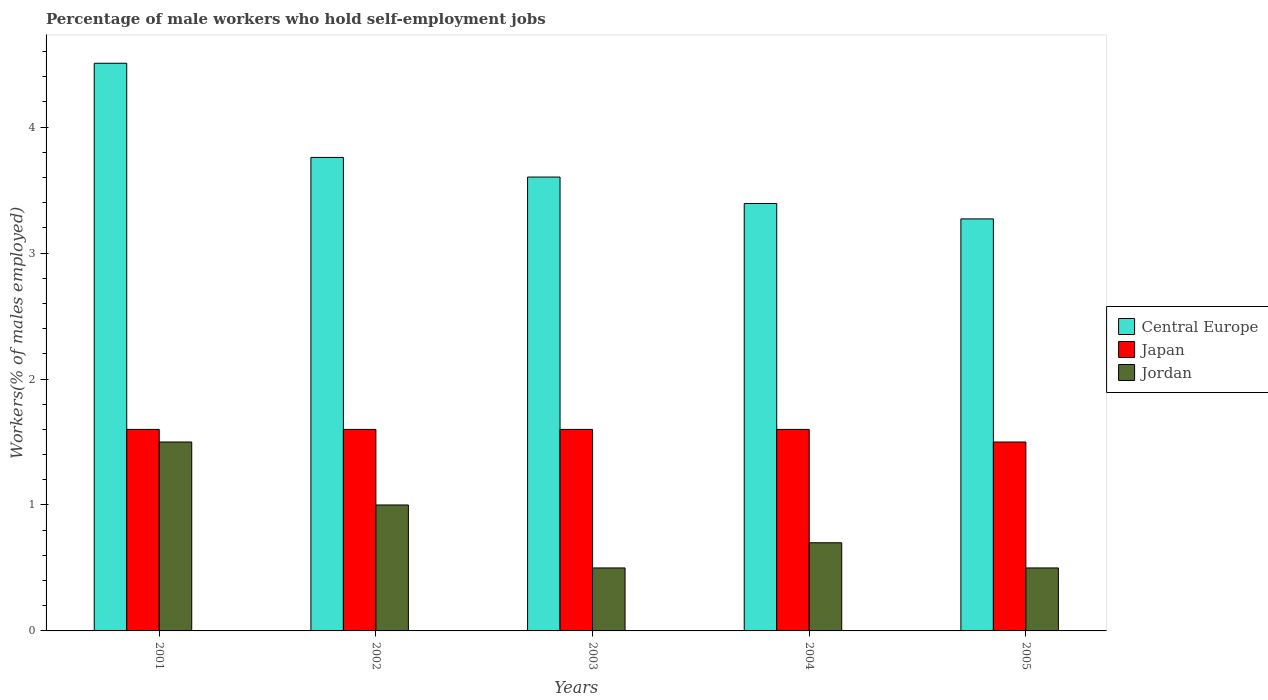How many different coloured bars are there?
Your response must be concise. 3. Are the number of bars per tick equal to the number of legend labels?
Make the answer very short. Yes. How many bars are there on the 3rd tick from the left?
Provide a succinct answer. 3. How many bars are there on the 5th tick from the right?
Your answer should be very brief. 3. In how many cases, is the number of bars for a given year not equal to the number of legend labels?
Provide a short and direct response. 0. What is the percentage of self-employed male workers in Central Europe in 2002?
Your answer should be compact. 3.76. Across all years, what is the minimum percentage of self-employed male workers in Central Europe?
Your response must be concise. 3.27. In which year was the percentage of self-employed male workers in Central Europe minimum?
Offer a terse response. 2005. What is the total percentage of self-employed male workers in Japan in the graph?
Your response must be concise. 7.9. What is the difference between the percentage of self-employed male workers in Jordan in 2004 and that in 2005?
Make the answer very short. 0.2. What is the difference between the percentage of self-employed male workers in Jordan in 2001 and the percentage of self-employed male workers in Japan in 2002?
Your answer should be compact. -0.1. What is the average percentage of self-employed male workers in Jordan per year?
Make the answer very short. 0.84. In the year 2002, what is the difference between the percentage of self-employed male workers in Jordan and percentage of self-employed male workers in Central Europe?
Give a very brief answer. -2.76. What is the ratio of the percentage of self-employed male workers in Central Europe in 2003 to that in 2005?
Provide a succinct answer. 1.1. Is the percentage of self-employed male workers in Central Europe in 2001 less than that in 2004?
Make the answer very short. No. What is the difference between the highest and the second highest percentage of self-employed male workers in Central Europe?
Your response must be concise. 0.75. What is the difference between the highest and the lowest percentage of self-employed male workers in Central Europe?
Keep it short and to the point. 1.24. In how many years, is the percentage of self-employed male workers in Central Europe greater than the average percentage of self-employed male workers in Central Europe taken over all years?
Ensure brevity in your answer.  2. Is the sum of the percentage of self-employed male workers in Jordan in 2001 and 2002 greater than the maximum percentage of self-employed male workers in Japan across all years?
Your response must be concise. Yes. What does the 1st bar from the left in 2004 represents?
Your answer should be compact. Central Europe. Is it the case that in every year, the sum of the percentage of self-employed male workers in Japan and percentage of self-employed male workers in Central Europe is greater than the percentage of self-employed male workers in Jordan?
Provide a succinct answer. Yes. How many bars are there?
Your answer should be very brief. 15. What is the difference between two consecutive major ticks on the Y-axis?
Offer a very short reply. 1. Where does the legend appear in the graph?
Your answer should be compact. Center right. How many legend labels are there?
Offer a terse response. 3. What is the title of the graph?
Your answer should be compact. Percentage of male workers who hold self-employment jobs. Does "Solomon Islands" appear as one of the legend labels in the graph?
Your answer should be very brief. No. What is the label or title of the X-axis?
Give a very brief answer. Years. What is the label or title of the Y-axis?
Your response must be concise. Workers(% of males employed). What is the Workers(% of males employed) in Central Europe in 2001?
Make the answer very short. 4.51. What is the Workers(% of males employed) in Japan in 2001?
Keep it short and to the point. 1.6. What is the Workers(% of males employed) of Jordan in 2001?
Ensure brevity in your answer.  1.5. What is the Workers(% of males employed) of Central Europe in 2002?
Give a very brief answer. 3.76. What is the Workers(% of males employed) in Japan in 2002?
Your response must be concise. 1.6. What is the Workers(% of males employed) of Central Europe in 2003?
Provide a short and direct response. 3.6. What is the Workers(% of males employed) of Japan in 2003?
Provide a succinct answer. 1.6. What is the Workers(% of males employed) in Jordan in 2003?
Your answer should be very brief. 0.5. What is the Workers(% of males employed) in Central Europe in 2004?
Your answer should be very brief. 3.39. What is the Workers(% of males employed) of Japan in 2004?
Offer a very short reply. 1.6. What is the Workers(% of males employed) in Jordan in 2004?
Provide a short and direct response. 0.7. What is the Workers(% of males employed) of Central Europe in 2005?
Ensure brevity in your answer.  3.27. What is the Workers(% of males employed) in Jordan in 2005?
Ensure brevity in your answer.  0.5. Across all years, what is the maximum Workers(% of males employed) of Central Europe?
Ensure brevity in your answer.  4.51. Across all years, what is the maximum Workers(% of males employed) of Japan?
Your response must be concise. 1.6. Across all years, what is the maximum Workers(% of males employed) in Jordan?
Give a very brief answer. 1.5. Across all years, what is the minimum Workers(% of males employed) of Central Europe?
Provide a succinct answer. 3.27. Across all years, what is the minimum Workers(% of males employed) in Japan?
Give a very brief answer. 1.5. Across all years, what is the minimum Workers(% of males employed) in Jordan?
Make the answer very short. 0.5. What is the total Workers(% of males employed) in Central Europe in the graph?
Give a very brief answer. 18.54. What is the difference between the Workers(% of males employed) of Central Europe in 2001 and that in 2002?
Provide a succinct answer. 0.75. What is the difference between the Workers(% of males employed) in Central Europe in 2001 and that in 2003?
Make the answer very short. 0.9. What is the difference between the Workers(% of males employed) in Central Europe in 2001 and that in 2004?
Provide a short and direct response. 1.11. What is the difference between the Workers(% of males employed) of Japan in 2001 and that in 2004?
Provide a succinct answer. 0. What is the difference between the Workers(% of males employed) of Central Europe in 2001 and that in 2005?
Keep it short and to the point. 1.24. What is the difference between the Workers(% of males employed) of Jordan in 2001 and that in 2005?
Offer a very short reply. 1. What is the difference between the Workers(% of males employed) of Central Europe in 2002 and that in 2003?
Your answer should be compact. 0.16. What is the difference between the Workers(% of males employed) of Central Europe in 2002 and that in 2004?
Make the answer very short. 0.37. What is the difference between the Workers(% of males employed) in Japan in 2002 and that in 2004?
Make the answer very short. 0. What is the difference between the Workers(% of males employed) of Central Europe in 2002 and that in 2005?
Keep it short and to the point. 0.49. What is the difference between the Workers(% of males employed) of Central Europe in 2003 and that in 2004?
Offer a terse response. 0.21. What is the difference between the Workers(% of males employed) of Central Europe in 2003 and that in 2005?
Make the answer very short. 0.33. What is the difference between the Workers(% of males employed) of Japan in 2003 and that in 2005?
Provide a short and direct response. 0.1. What is the difference between the Workers(% of males employed) of Central Europe in 2004 and that in 2005?
Provide a succinct answer. 0.12. What is the difference between the Workers(% of males employed) in Japan in 2004 and that in 2005?
Your answer should be very brief. 0.1. What is the difference between the Workers(% of males employed) of Central Europe in 2001 and the Workers(% of males employed) of Japan in 2002?
Your answer should be compact. 2.91. What is the difference between the Workers(% of males employed) in Central Europe in 2001 and the Workers(% of males employed) in Jordan in 2002?
Ensure brevity in your answer.  3.51. What is the difference between the Workers(% of males employed) of Japan in 2001 and the Workers(% of males employed) of Jordan in 2002?
Your answer should be compact. 0.6. What is the difference between the Workers(% of males employed) of Central Europe in 2001 and the Workers(% of males employed) of Japan in 2003?
Keep it short and to the point. 2.91. What is the difference between the Workers(% of males employed) in Central Europe in 2001 and the Workers(% of males employed) in Jordan in 2003?
Offer a terse response. 4.01. What is the difference between the Workers(% of males employed) in Japan in 2001 and the Workers(% of males employed) in Jordan in 2003?
Offer a very short reply. 1.1. What is the difference between the Workers(% of males employed) of Central Europe in 2001 and the Workers(% of males employed) of Japan in 2004?
Make the answer very short. 2.91. What is the difference between the Workers(% of males employed) in Central Europe in 2001 and the Workers(% of males employed) in Jordan in 2004?
Make the answer very short. 3.81. What is the difference between the Workers(% of males employed) in Central Europe in 2001 and the Workers(% of males employed) in Japan in 2005?
Provide a short and direct response. 3.01. What is the difference between the Workers(% of males employed) of Central Europe in 2001 and the Workers(% of males employed) of Jordan in 2005?
Give a very brief answer. 4.01. What is the difference between the Workers(% of males employed) of Central Europe in 2002 and the Workers(% of males employed) of Japan in 2003?
Your answer should be very brief. 2.16. What is the difference between the Workers(% of males employed) in Central Europe in 2002 and the Workers(% of males employed) in Jordan in 2003?
Your response must be concise. 3.26. What is the difference between the Workers(% of males employed) of Central Europe in 2002 and the Workers(% of males employed) of Japan in 2004?
Offer a very short reply. 2.16. What is the difference between the Workers(% of males employed) in Central Europe in 2002 and the Workers(% of males employed) in Jordan in 2004?
Give a very brief answer. 3.06. What is the difference between the Workers(% of males employed) in Japan in 2002 and the Workers(% of males employed) in Jordan in 2004?
Make the answer very short. 0.9. What is the difference between the Workers(% of males employed) in Central Europe in 2002 and the Workers(% of males employed) in Japan in 2005?
Keep it short and to the point. 2.26. What is the difference between the Workers(% of males employed) in Central Europe in 2002 and the Workers(% of males employed) in Jordan in 2005?
Ensure brevity in your answer.  3.26. What is the difference between the Workers(% of males employed) in Japan in 2002 and the Workers(% of males employed) in Jordan in 2005?
Your response must be concise. 1.1. What is the difference between the Workers(% of males employed) of Central Europe in 2003 and the Workers(% of males employed) of Japan in 2004?
Give a very brief answer. 2. What is the difference between the Workers(% of males employed) of Central Europe in 2003 and the Workers(% of males employed) of Jordan in 2004?
Ensure brevity in your answer.  2.9. What is the difference between the Workers(% of males employed) in Japan in 2003 and the Workers(% of males employed) in Jordan in 2004?
Provide a succinct answer. 0.9. What is the difference between the Workers(% of males employed) in Central Europe in 2003 and the Workers(% of males employed) in Japan in 2005?
Your response must be concise. 2.1. What is the difference between the Workers(% of males employed) of Central Europe in 2003 and the Workers(% of males employed) of Jordan in 2005?
Your response must be concise. 3.1. What is the difference between the Workers(% of males employed) in Central Europe in 2004 and the Workers(% of males employed) in Japan in 2005?
Your answer should be compact. 1.89. What is the difference between the Workers(% of males employed) in Central Europe in 2004 and the Workers(% of males employed) in Jordan in 2005?
Your answer should be compact. 2.89. What is the difference between the Workers(% of males employed) in Japan in 2004 and the Workers(% of males employed) in Jordan in 2005?
Make the answer very short. 1.1. What is the average Workers(% of males employed) in Central Europe per year?
Ensure brevity in your answer.  3.71. What is the average Workers(% of males employed) of Japan per year?
Your response must be concise. 1.58. What is the average Workers(% of males employed) in Jordan per year?
Your response must be concise. 0.84. In the year 2001, what is the difference between the Workers(% of males employed) in Central Europe and Workers(% of males employed) in Japan?
Ensure brevity in your answer.  2.91. In the year 2001, what is the difference between the Workers(% of males employed) in Central Europe and Workers(% of males employed) in Jordan?
Give a very brief answer. 3.01. In the year 2002, what is the difference between the Workers(% of males employed) in Central Europe and Workers(% of males employed) in Japan?
Provide a succinct answer. 2.16. In the year 2002, what is the difference between the Workers(% of males employed) of Central Europe and Workers(% of males employed) of Jordan?
Provide a succinct answer. 2.76. In the year 2002, what is the difference between the Workers(% of males employed) in Japan and Workers(% of males employed) in Jordan?
Give a very brief answer. 0.6. In the year 2003, what is the difference between the Workers(% of males employed) of Central Europe and Workers(% of males employed) of Japan?
Offer a terse response. 2. In the year 2003, what is the difference between the Workers(% of males employed) of Central Europe and Workers(% of males employed) of Jordan?
Your answer should be very brief. 3.1. In the year 2004, what is the difference between the Workers(% of males employed) of Central Europe and Workers(% of males employed) of Japan?
Your response must be concise. 1.79. In the year 2004, what is the difference between the Workers(% of males employed) of Central Europe and Workers(% of males employed) of Jordan?
Make the answer very short. 2.69. In the year 2005, what is the difference between the Workers(% of males employed) in Central Europe and Workers(% of males employed) in Japan?
Your answer should be compact. 1.77. In the year 2005, what is the difference between the Workers(% of males employed) of Central Europe and Workers(% of males employed) of Jordan?
Ensure brevity in your answer.  2.77. In the year 2005, what is the difference between the Workers(% of males employed) of Japan and Workers(% of males employed) of Jordan?
Make the answer very short. 1. What is the ratio of the Workers(% of males employed) of Central Europe in 2001 to that in 2002?
Your answer should be compact. 1.2. What is the ratio of the Workers(% of males employed) of Central Europe in 2001 to that in 2003?
Your response must be concise. 1.25. What is the ratio of the Workers(% of males employed) in Jordan in 2001 to that in 2003?
Ensure brevity in your answer.  3. What is the ratio of the Workers(% of males employed) in Central Europe in 2001 to that in 2004?
Provide a short and direct response. 1.33. What is the ratio of the Workers(% of males employed) of Jordan in 2001 to that in 2004?
Provide a short and direct response. 2.14. What is the ratio of the Workers(% of males employed) of Central Europe in 2001 to that in 2005?
Your answer should be very brief. 1.38. What is the ratio of the Workers(% of males employed) of Japan in 2001 to that in 2005?
Offer a terse response. 1.07. What is the ratio of the Workers(% of males employed) of Jordan in 2001 to that in 2005?
Keep it short and to the point. 3. What is the ratio of the Workers(% of males employed) of Central Europe in 2002 to that in 2003?
Make the answer very short. 1.04. What is the ratio of the Workers(% of males employed) of Jordan in 2002 to that in 2003?
Your answer should be compact. 2. What is the ratio of the Workers(% of males employed) of Central Europe in 2002 to that in 2004?
Keep it short and to the point. 1.11. What is the ratio of the Workers(% of males employed) of Japan in 2002 to that in 2004?
Your answer should be very brief. 1. What is the ratio of the Workers(% of males employed) in Jordan in 2002 to that in 2004?
Provide a short and direct response. 1.43. What is the ratio of the Workers(% of males employed) of Central Europe in 2002 to that in 2005?
Your response must be concise. 1.15. What is the ratio of the Workers(% of males employed) of Japan in 2002 to that in 2005?
Ensure brevity in your answer.  1.07. What is the ratio of the Workers(% of males employed) of Jordan in 2002 to that in 2005?
Ensure brevity in your answer.  2. What is the ratio of the Workers(% of males employed) of Central Europe in 2003 to that in 2004?
Offer a very short reply. 1.06. What is the ratio of the Workers(% of males employed) in Jordan in 2003 to that in 2004?
Keep it short and to the point. 0.71. What is the ratio of the Workers(% of males employed) of Central Europe in 2003 to that in 2005?
Your answer should be very brief. 1.1. What is the ratio of the Workers(% of males employed) of Japan in 2003 to that in 2005?
Offer a very short reply. 1.07. What is the ratio of the Workers(% of males employed) of Central Europe in 2004 to that in 2005?
Offer a terse response. 1.04. What is the ratio of the Workers(% of males employed) of Japan in 2004 to that in 2005?
Ensure brevity in your answer.  1.07. What is the difference between the highest and the second highest Workers(% of males employed) of Central Europe?
Give a very brief answer. 0.75. What is the difference between the highest and the second highest Workers(% of males employed) of Japan?
Give a very brief answer. 0. What is the difference between the highest and the second highest Workers(% of males employed) in Jordan?
Provide a succinct answer. 0.5. What is the difference between the highest and the lowest Workers(% of males employed) of Central Europe?
Ensure brevity in your answer.  1.24. What is the difference between the highest and the lowest Workers(% of males employed) of Japan?
Provide a short and direct response. 0.1. What is the difference between the highest and the lowest Workers(% of males employed) of Jordan?
Your answer should be compact. 1. 